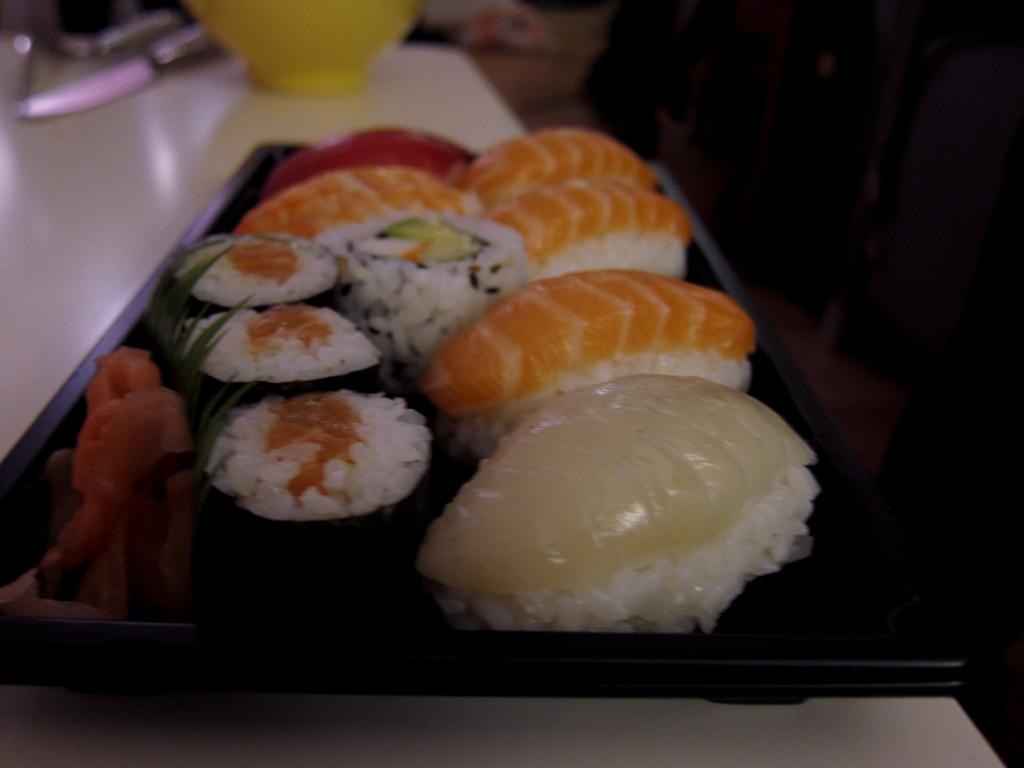What is the color of the tray in the image? The tray in the image is black. What is on the tray? Food items are present in the tray. Can you describe the colors of the food items? The food has various colors, including white, orange, cream, and red. How many objects can be seen in the image? There are a few objects visible in the image. What is the color of the surface the tray is placed on? The tray is placed on a white color surface. What type of shoe is visible in the image? There is no shoe present in the image. Is the group of people planning a voyage in the image? There is no group of people or any indication of a voyage in the image. 